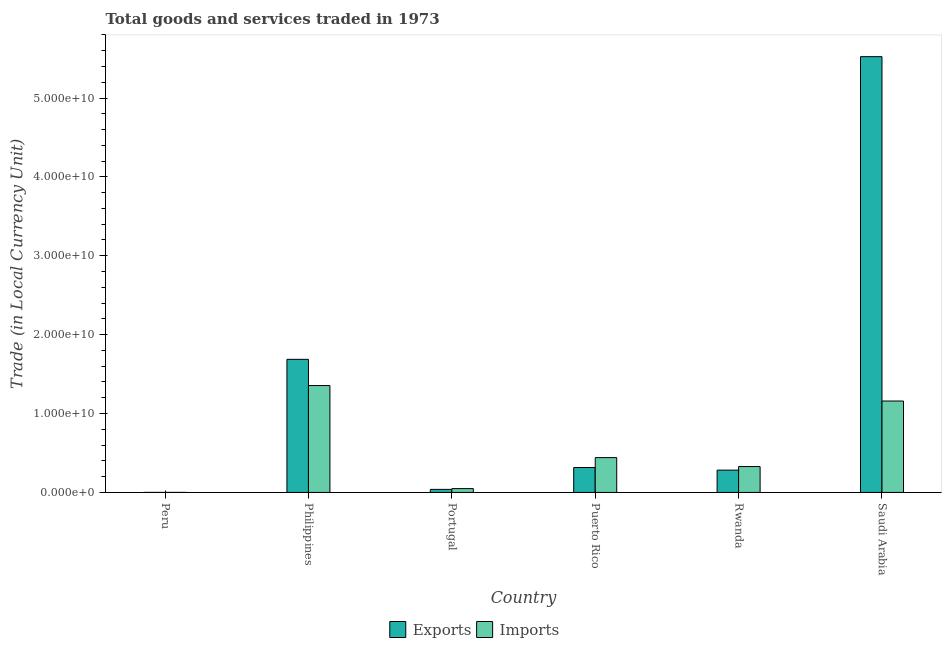How many different coloured bars are there?
Provide a short and direct response. 2. How many groups of bars are there?
Offer a very short reply. 6. How many bars are there on the 3rd tick from the left?
Make the answer very short. 2. What is the label of the 3rd group of bars from the left?
Provide a short and direct response. Portugal. In how many cases, is the number of bars for a given country not equal to the number of legend labels?
Your answer should be very brief. 0. What is the export of goods and services in Rwanda?
Give a very brief answer. 2.83e+09. Across all countries, what is the maximum imports of goods and services?
Your response must be concise. 1.35e+1. Across all countries, what is the minimum imports of goods and services?
Make the answer very short. 65.3. In which country was the imports of goods and services maximum?
Your answer should be compact. Philippines. What is the total export of goods and services in the graph?
Provide a succinct answer. 7.85e+1. What is the difference between the imports of goods and services in Philippines and that in Rwanda?
Your answer should be very brief. 1.03e+1. What is the difference between the export of goods and services in Puerto Rico and the imports of goods and services in Rwanda?
Your answer should be very brief. -1.21e+08. What is the average imports of goods and services per country?
Offer a very short reply. 5.55e+09. What is the difference between the imports of goods and services and export of goods and services in Portugal?
Provide a succinct answer. 9.89e+07. What is the ratio of the imports of goods and services in Rwanda to that in Saudi Arabia?
Your answer should be very brief. 0.28. What is the difference between the highest and the second highest imports of goods and services?
Offer a very short reply. 1.96e+09. What is the difference between the highest and the lowest export of goods and services?
Ensure brevity in your answer.  5.52e+1. Is the sum of the export of goods and services in Peru and Portugal greater than the maximum imports of goods and services across all countries?
Provide a succinct answer. No. What does the 2nd bar from the left in Saudi Arabia represents?
Your answer should be compact. Imports. What does the 2nd bar from the right in Peru represents?
Offer a terse response. Exports. Does the graph contain any zero values?
Your response must be concise. No. Does the graph contain grids?
Give a very brief answer. No. How are the legend labels stacked?
Give a very brief answer. Horizontal. What is the title of the graph?
Offer a very short reply. Total goods and services traded in 1973. What is the label or title of the Y-axis?
Offer a very short reply. Trade (in Local Currency Unit). What is the Trade (in Local Currency Unit) of Exports in Peru?
Give a very brief answer. 56.7. What is the Trade (in Local Currency Unit) in Imports in Peru?
Your response must be concise. 65.3. What is the Trade (in Local Currency Unit) in Exports in Philippines?
Keep it short and to the point. 1.69e+1. What is the Trade (in Local Currency Unit) in Imports in Philippines?
Offer a very short reply. 1.35e+1. What is the Trade (in Local Currency Unit) of Exports in Portugal?
Keep it short and to the point. 3.86e+08. What is the Trade (in Local Currency Unit) in Imports in Portugal?
Keep it short and to the point. 4.85e+08. What is the Trade (in Local Currency Unit) in Exports in Puerto Rico?
Your answer should be compact. 3.16e+09. What is the Trade (in Local Currency Unit) in Imports in Puerto Rico?
Your answer should be compact. 4.42e+09. What is the Trade (in Local Currency Unit) of Exports in Rwanda?
Your answer should be very brief. 2.83e+09. What is the Trade (in Local Currency Unit) in Imports in Rwanda?
Provide a succinct answer. 3.28e+09. What is the Trade (in Local Currency Unit) of Exports in Saudi Arabia?
Keep it short and to the point. 5.52e+1. What is the Trade (in Local Currency Unit) of Imports in Saudi Arabia?
Provide a succinct answer. 1.16e+1. Across all countries, what is the maximum Trade (in Local Currency Unit) in Exports?
Keep it short and to the point. 5.52e+1. Across all countries, what is the maximum Trade (in Local Currency Unit) in Imports?
Give a very brief answer. 1.35e+1. Across all countries, what is the minimum Trade (in Local Currency Unit) in Exports?
Your answer should be very brief. 56.7. Across all countries, what is the minimum Trade (in Local Currency Unit) of Imports?
Your answer should be compact. 65.3. What is the total Trade (in Local Currency Unit) in Exports in the graph?
Give a very brief answer. 7.85e+1. What is the total Trade (in Local Currency Unit) of Imports in the graph?
Your response must be concise. 3.33e+1. What is the difference between the Trade (in Local Currency Unit) of Exports in Peru and that in Philippines?
Provide a succinct answer. -1.69e+1. What is the difference between the Trade (in Local Currency Unit) of Imports in Peru and that in Philippines?
Provide a short and direct response. -1.35e+1. What is the difference between the Trade (in Local Currency Unit) in Exports in Peru and that in Portugal?
Provide a succinct answer. -3.86e+08. What is the difference between the Trade (in Local Currency Unit) in Imports in Peru and that in Portugal?
Provide a short and direct response. -4.85e+08. What is the difference between the Trade (in Local Currency Unit) of Exports in Peru and that in Puerto Rico?
Your answer should be compact. -3.16e+09. What is the difference between the Trade (in Local Currency Unit) in Imports in Peru and that in Puerto Rico?
Make the answer very short. -4.41e+09. What is the difference between the Trade (in Local Currency Unit) in Exports in Peru and that in Rwanda?
Ensure brevity in your answer.  -2.83e+09. What is the difference between the Trade (in Local Currency Unit) in Imports in Peru and that in Rwanda?
Make the answer very short. -3.28e+09. What is the difference between the Trade (in Local Currency Unit) of Exports in Peru and that in Saudi Arabia?
Provide a succinct answer. -5.52e+1. What is the difference between the Trade (in Local Currency Unit) of Imports in Peru and that in Saudi Arabia?
Ensure brevity in your answer.  -1.16e+1. What is the difference between the Trade (in Local Currency Unit) of Exports in Philippines and that in Portugal?
Your answer should be compact. 1.65e+1. What is the difference between the Trade (in Local Currency Unit) in Imports in Philippines and that in Portugal?
Your answer should be compact. 1.31e+1. What is the difference between the Trade (in Local Currency Unit) of Exports in Philippines and that in Puerto Rico?
Ensure brevity in your answer.  1.37e+1. What is the difference between the Trade (in Local Currency Unit) in Imports in Philippines and that in Puerto Rico?
Your answer should be very brief. 9.13e+09. What is the difference between the Trade (in Local Currency Unit) in Exports in Philippines and that in Rwanda?
Provide a succinct answer. 1.40e+1. What is the difference between the Trade (in Local Currency Unit) in Imports in Philippines and that in Rwanda?
Your answer should be very brief. 1.03e+1. What is the difference between the Trade (in Local Currency Unit) in Exports in Philippines and that in Saudi Arabia?
Give a very brief answer. -3.84e+1. What is the difference between the Trade (in Local Currency Unit) in Imports in Philippines and that in Saudi Arabia?
Your answer should be compact. 1.96e+09. What is the difference between the Trade (in Local Currency Unit) of Exports in Portugal and that in Puerto Rico?
Your answer should be very brief. -2.77e+09. What is the difference between the Trade (in Local Currency Unit) in Imports in Portugal and that in Puerto Rico?
Provide a short and direct response. -3.93e+09. What is the difference between the Trade (in Local Currency Unit) in Exports in Portugal and that in Rwanda?
Provide a short and direct response. -2.44e+09. What is the difference between the Trade (in Local Currency Unit) in Imports in Portugal and that in Rwanda?
Your response must be concise. -2.79e+09. What is the difference between the Trade (in Local Currency Unit) of Exports in Portugal and that in Saudi Arabia?
Ensure brevity in your answer.  -5.49e+1. What is the difference between the Trade (in Local Currency Unit) of Imports in Portugal and that in Saudi Arabia?
Make the answer very short. -1.11e+1. What is the difference between the Trade (in Local Currency Unit) in Exports in Puerto Rico and that in Rwanda?
Your answer should be compact. 3.29e+08. What is the difference between the Trade (in Local Currency Unit) in Imports in Puerto Rico and that in Rwanda?
Provide a succinct answer. 1.14e+09. What is the difference between the Trade (in Local Currency Unit) of Exports in Puerto Rico and that in Saudi Arabia?
Your response must be concise. -5.21e+1. What is the difference between the Trade (in Local Currency Unit) of Imports in Puerto Rico and that in Saudi Arabia?
Offer a terse response. -7.17e+09. What is the difference between the Trade (in Local Currency Unit) of Exports in Rwanda and that in Saudi Arabia?
Make the answer very short. -5.24e+1. What is the difference between the Trade (in Local Currency Unit) in Imports in Rwanda and that in Saudi Arabia?
Your response must be concise. -8.31e+09. What is the difference between the Trade (in Local Currency Unit) in Exports in Peru and the Trade (in Local Currency Unit) in Imports in Philippines?
Give a very brief answer. -1.35e+1. What is the difference between the Trade (in Local Currency Unit) in Exports in Peru and the Trade (in Local Currency Unit) in Imports in Portugal?
Give a very brief answer. -4.85e+08. What is the difference between the Trade (in Local Currency Unit) of Exports in Peru and the Trade (in Local Currency Unit) of Imports in Puerto Rico?
Offer a terse response. -4.41e+09. What is the difference between the Trade (in Local Currency Unit) in Exports in Peru and the Trade (in Local Currency Unit) in Imports in Rwanda?
Make the answer very short. -3.28e+09. What is the difference between the Trade (in Local Currency Unit) of Exports in Peru and the Trade (in Local Currency Unit) of Imports in Saudi Arabia?
Make the answer very short. -1.16e+1. What is the difference between the Trade (in Local Currency Unit) of Exports in Philippines and the Trade (in Local Currency Unit) of Imports in Portugal?
Your answer should be compact. 1.64e+1. What is the difference between the Trade (in Local Currency Unit) of Exports in Philippines and the Trade (in Local Currency Unit) of Imports in Puerto Rico?
Ensure brevity in your answer.  1.25e+1. What is the difference between the Trade (in Local Currency Unit) in Exports in Philippines and the Trade (in Local Currency Unit) in Imports in Rwanda?
Your answer should be compact. 1.36e+1. What is the difference between the Trade (in Local Currency Unit) in Exports in Philippines and the Trade (in Local Currency Unit) in Imports in Saudi Arabia?
Your answer should be compact. 5.28e+09. What is the difference between the Trade (in Local Currency Unit) in Exports in Portugal and the Trade (in Local Currency Unit) in Imports in Puerto Rico?
Offer a terse response. -4.03e+09. What is the difference between the Trade (in Local Currency Unit) in Exports in Portugal and the Trade (in Local Currency Unit) in Imports in Rwanda?
Provide a succinct answer. -2.89e+09. What is the difference between the Trade (in Local Currency Unit) of Exports in Portugal and the Trade (in Local Currency Unit) of Imports in Saudi Arabia?
Offer a terse response. -1.12e+1. What is the difference between the Trade (in Local Currency Unit) of Exports in Puerto Rico and the Trade (in Local Currency Unit) of Imports in Rwanda?
Offer a very short reply. -1.21e+08. What is the difference between the Trade (in Local Currency Unit) of Exports in Puerto Rico and the Trade (in Local Currency Unit) of Imports in Saudi Arabia?
Your answer should be compact. -8.43e+09. What is the difference between the Trade (in Local Currency Unit) of Exports in Rwanda and the Trade (in Local Currency Unit) of Imports in Saudi Arabia?
Keep it short and to the point. -8.76e+09. What is the average Trade (in Local Currency Unit) of Exports per country?
Your answer should be compact. 1.31e+1. What is the average Trade (in Local Currency Unit) of Imports per country?
Your response must be concise. 5.55e+09. What is the difference between the Trade (in Local Currency Unit) in Exports and Trade (in Local Currency Unit) in Imports in Philippines?
Provide a short and direct response. 3.32e+09. What is the difference between the Trade (in Local Currency Unit) of Exports and Trade (in Local Currency Unit) of Imports in Portugal?
Give a very brief answer. -9.89e+07. What is the difference between the Trade (in Local Currency Unit) in Exports and Trade (in Local Currency Unit) in Imports in Puerto Rico?
Your answer should be compact. -1.26e+09. What is the difference between the Trade (in Local Currency Unit) in Exports and Trade (in Local Currency Unit) in Imports in Rwanda?
Provide a short and direct response. -4.50e+08. What is the difference between the Trade (in Local Currency Unit) of Exports and Trade (in Local Currency Unit) of Imports in Saudi Arabia?
Make the answer very short. 4.37e+1. What is the ratio of the Trade (in Local Currency Unit) of Exports in Peru to that in Philippines?
Your response must be concise. 0. What is the ratio of the Trade (in Local Currency Unit) in Imports in Peru to that in Philippines?
Keep it short and to the point. 0. What is the ratio of the Trade (in Local Currency Unit) in Exports in Peru to that in Portugal?
Ensure brevity in your answer.  0. What is the ratio of the Trade (in Local Currency Unit) of Exports in Philippines to that in Portugal?
Provide a short and direct response. 43.66. What is the ratio of the Trade (in Local Currency Unit) of Imports in Philippines to that in Portugal?
Your answer should be compact. 27.92. What is the ratio of the Trade (in Local Currency Unit) of Exports in Philippines to that in Puerto Rico?
Offer a very short reply. 5.34. What is the ratio of the Trade (in Local Currency Unit) in Imports in Philippines to that in Puerto Rico?
Offer a terse response. 3.07. What is the ratio of the Trade (in Local Currency Unit) of Exports in Philippines to that in Rwanda?
Give a very brief answer. 5.96. What is the ratio of the Trade (in Local Currency Unit) of Imports in Philippines to that in Rwanda?
Keep it short and to the point. 4.13. What is the ratio of the Trade (in Local Currency Unit) in Exports in Philippines to that in Saudi Arabia?
Keep it short and to the point. 0.31. What is the ratio of the Trade (in Local Currency Unit) in Imports in Philippines to that in Saudi Arabia?
Provide a succinct answer. 1.17. What is the ratio of the Trade (in Local Currency Unit) in Exports in Portugal to that in Puerto Rico?
Give a very brief answer. 0.12. What is the ratio of the Trade (in Local Currency Unit) in Imports in Portugal to that in Puerto Rico?
Offer a very short reply. 0.11. What is the ratio of the Trade (in Local Currency Unit) of Exports in Portugal to that in Rwanda?
Provide a succinct answer. 0.14. What is the ratio of the Trade (in Local Currency Unit) of Imports in Portugal to that in Rwanda?
Provide a succinct answer. 0.15. What is the ratio of the Trade (in Local Currency Unit) in Exports in Portugal to that in Saudi Arabia?
Your answer should be very brief. 0.01. What is the ratio of the Trade (in Local Currency Unit) of Imports in Portugal to that in Saudi Arabia?
Give a very brief answer. 0.04. What is the ratio of the Trade (in Local Currency Unit) of Exports in Puerto Rico to that in Rwanda?
Provide a short and direct response. 1.12. What is the ratio of the Trade (in Local Currency Unit) in Imports in Puerto Rico to that in Rwanda?
Give a very brief answer. 1.35. What is the ratio of the Trade (in Local Currency Unit) of Exports in Puerto Rico to that in Saudi Arabia?
Ensure brevity in your answer.  0.06. What is the ratio of the Trade (in Local Currency Unit) of Imports in Puerto Rico to that in Saudi Arabia?
Your answer should be compact. 0.38. What is the ratio of the Trade (in Local Currency Unit) in Exports in Rwanda to that in Saudi Arabia?
Your answer should be very brief. 0.05. What is the ratio of the Trade (in Local Currency Unit) of Imports in Rwanda to that in Saudi Arabia?
Your answer should be compact. 0.28. What is the difference between the highest and the second highest Trade (in Local Currency Unit) of Exports?
Offer a terse response. 3.84e+1. What is the difference between the highest and the second highest Trade (in Local Currency Unit) in Imports?
Offer a terse response. 1.96e+09. What is the difference between the highest and the lowest Trade (in Local Currency Unit) of Exports?
Your response must be concise. 5.52e+1. What is the difference between the highest and the lowest Trade (in Local Currency Unit) of Imports?
Your answer should be compact. 1.35e+1. 